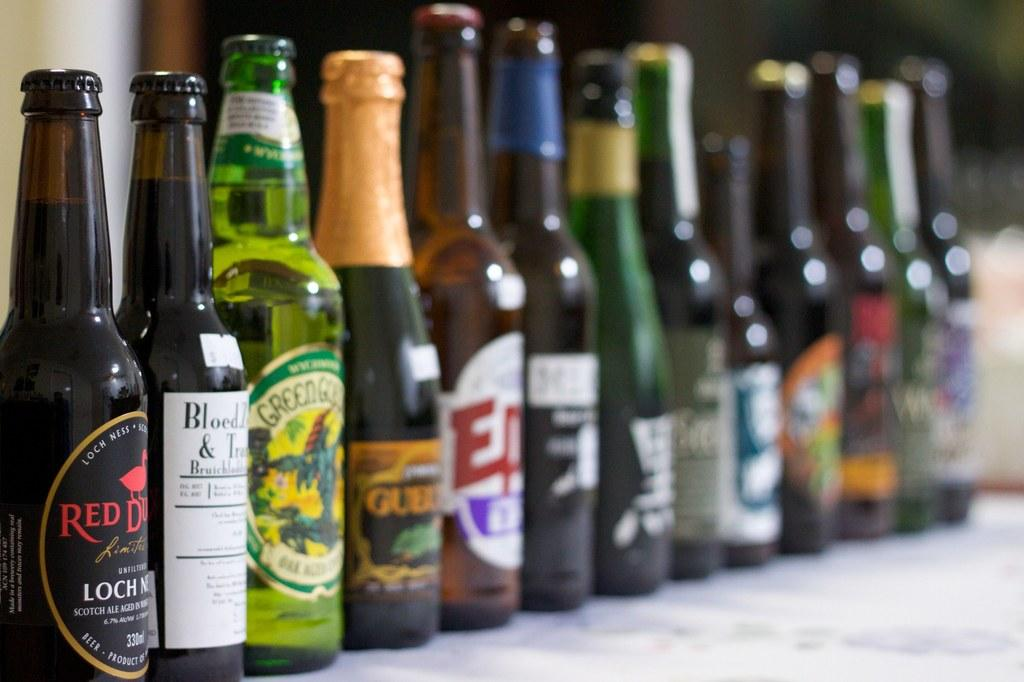<image>
Present a compact description of the photo's key features. A bottle of beer with the word "red" on it sits in a row of many beers. 